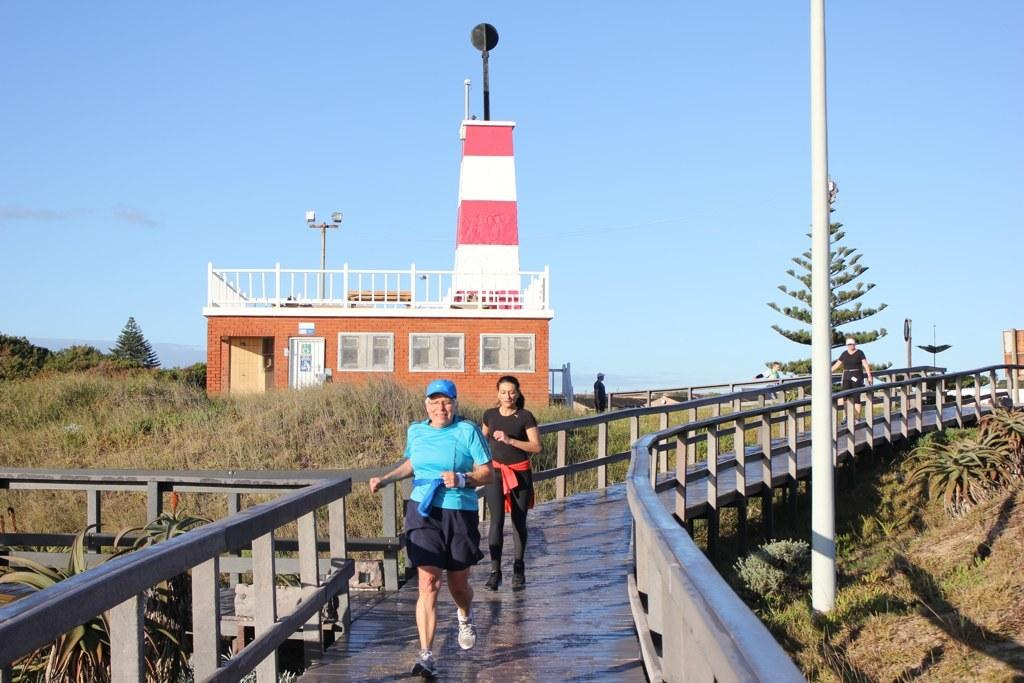How many people are in the image? There are three women in the image. What are the women doing in the image? The women are running on a bridge. What can be seen on the right side of the image? There is a pole on the right side of the image. What is visible in the background of the image? The background of the image is the sky. What type of test is being conducted on the bridge in the image? There is no test being conducted in the image; the women are simply running on the bridge. 